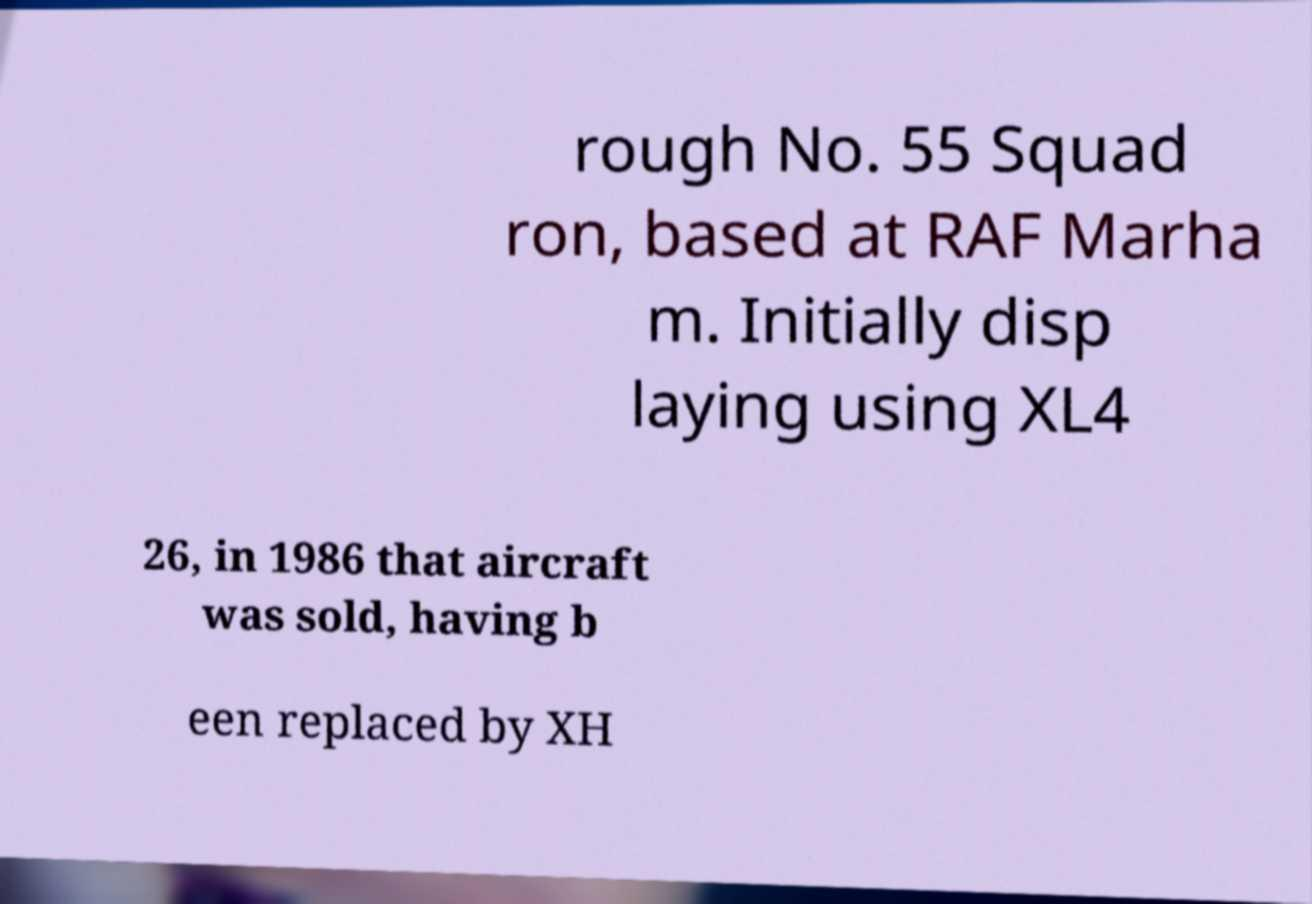Please identify and transcribe the text found in this image. rough No. 55 Squad ron, based at RAF Marha m. Initially disp laying using XL4 26, in 1986 that aircraft was sold, having b een replaced by XH 